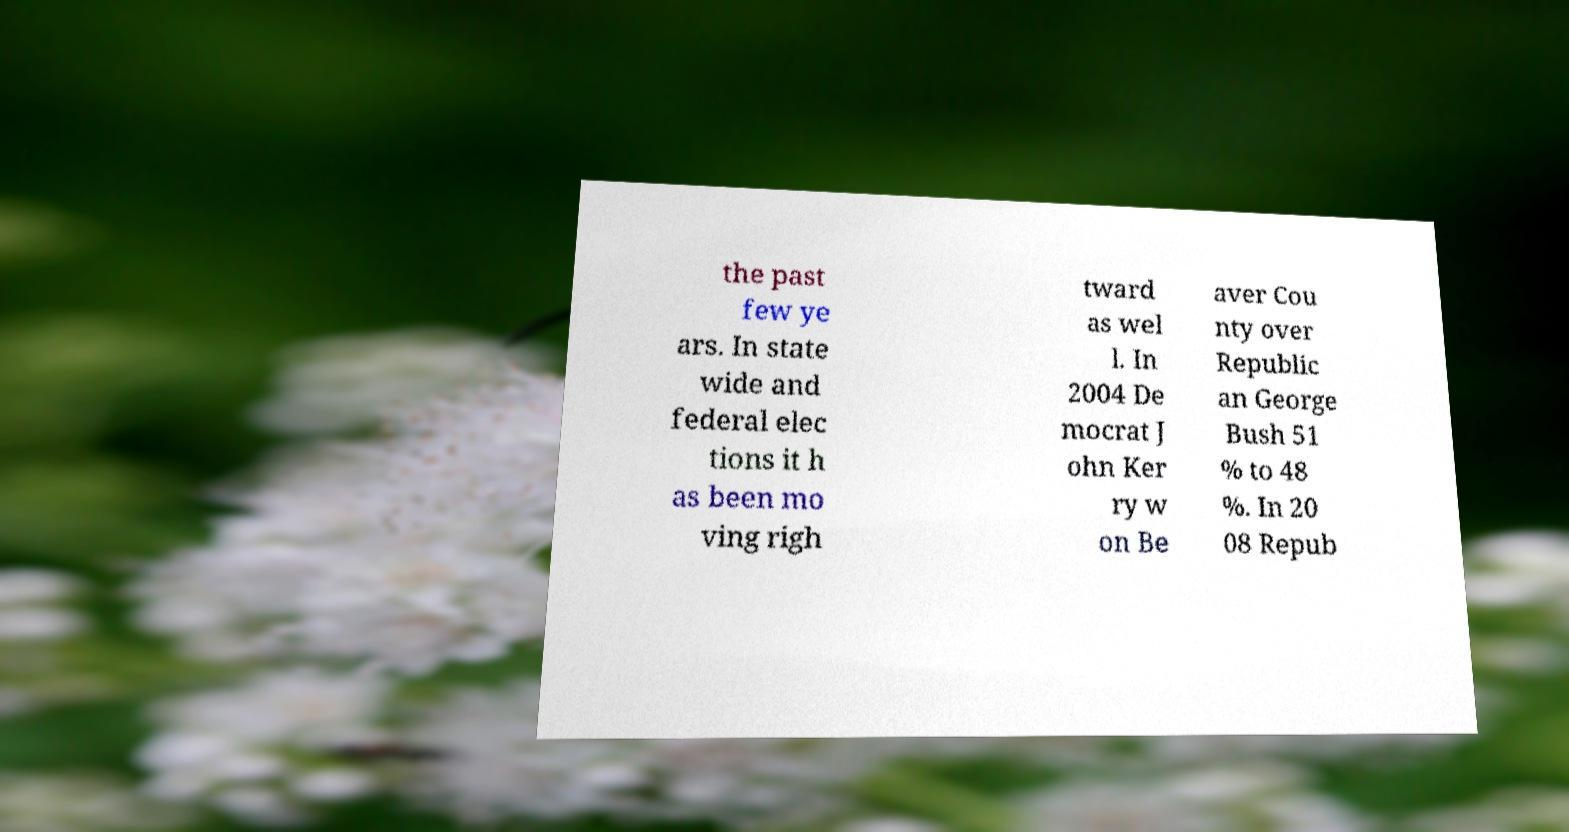Could you assist in decoding the text presented in this image and type it out clearly? the past few ye ars. In state wide and federal elec tions it h as been mo ving righ tward as wel l. In 2004 De mocrat J ohn Ker ry w on Be aver Cou nty over Republic an George Bush 51 % to 48 %. In 20 08 Repub 